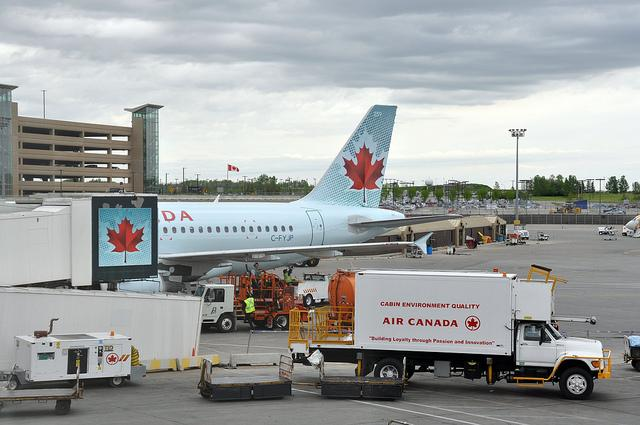What continent is this country located at? north america 